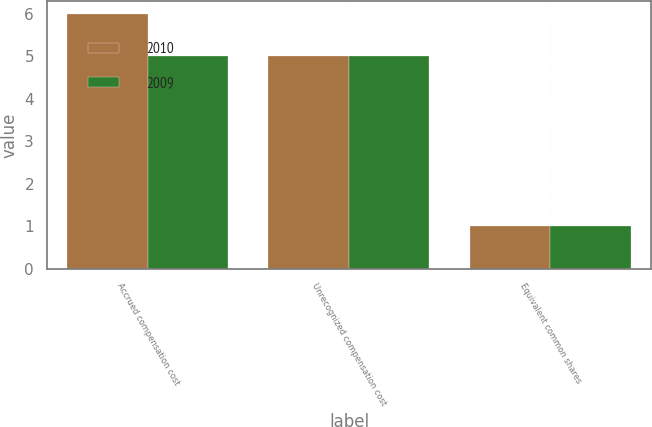<chart> <loc_0><loc_0><loc_500><loc_500><stacked_bar_chart><ecel><fcel>Accrued compensation cost<fcel>Unrecognized compensation cost<fcel>Equivalent common shares<nl><fcel>2010<fcel>6<fcel>5<fcel>1<nl><fcel>2009<fcel>5<fcel>5<fcel>1<nl></chart> 